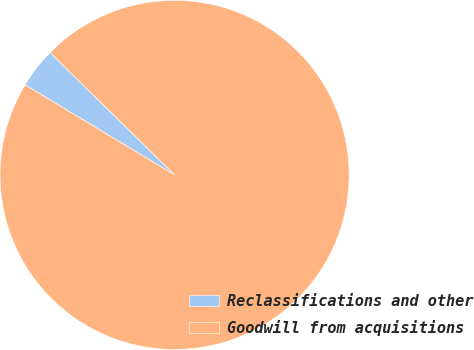Convert chart to OTSL. <chart><loc_0><loc_0><loc_500><loc_500><pie_chart><fcel>Reclassifications and other<fcel>Goodwill from acquisitions<nl><fcel>3.73%<fcel>96.27%<nl></chart> 